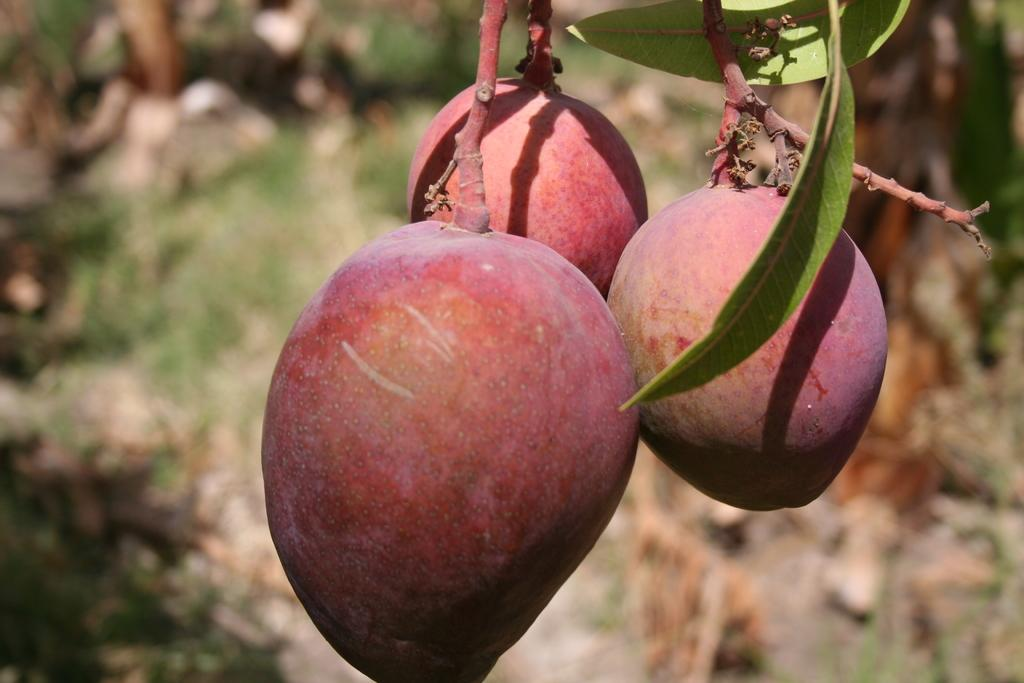What type of food can be seen in the image? There are fruits in the image. What colors are the fruits in the image? The fruits are red and orange in color. What else is present in the image besides the fruits? There are leaves in the image. What color are the leaves in the image? The leaves are green in color. How would you describe the background of the image? The background of the image is blurry. What type of jam can be seen dripping from the icicle in the image? There is no jam or icicle present in the image; it features fruits and leaves with a blurry background. 